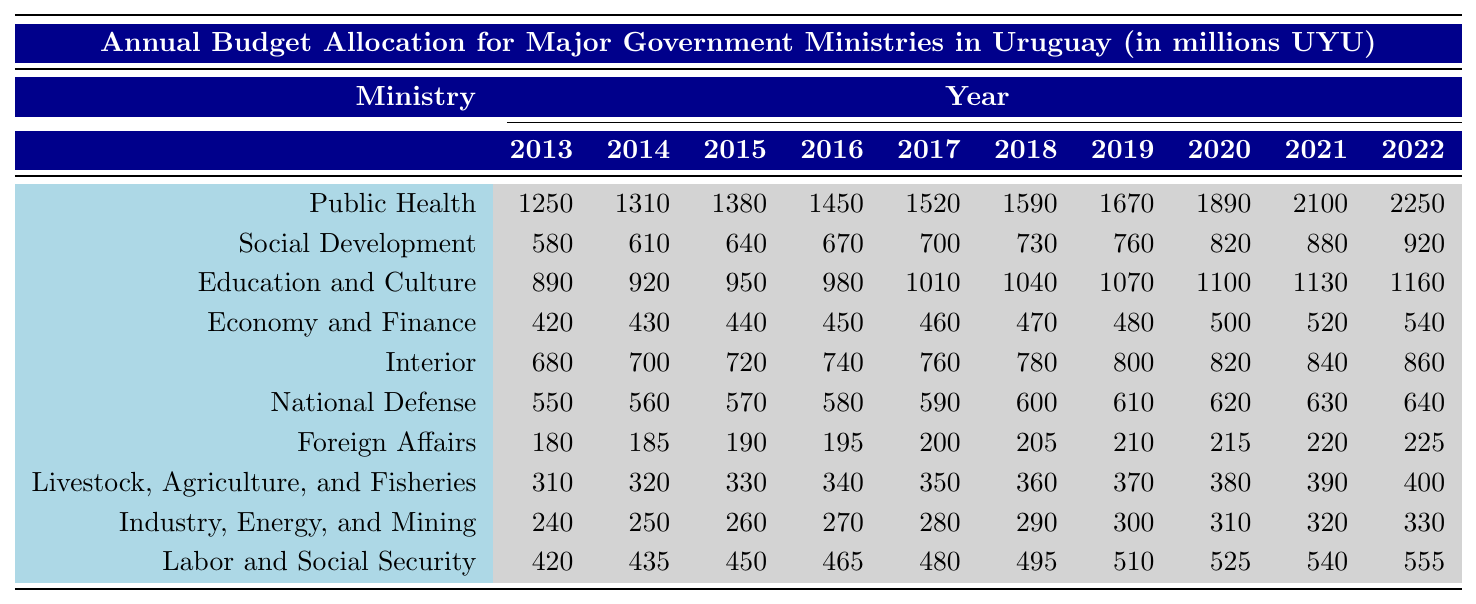What was the budget allocation for the Ministry of Public Health in 2020? In the column for the year 2020, the value for the Ministry of Public Health is listed directly as 1890.
Answer: 1890 Which ministry received the highest budget allocation in 2022? By examining the values for each ministry in the year 2022, the Ministry of Public Health has the highest value at 2250.
Answer: Ministry of Public Health What is the total budget allocated to the Ministry of Education and Culture over the last decade? To find the total, sum the values from 2013 to 2022: 890 + 920 + 950 + 980 + 1010 + 1040 + 1070 + 1100 + 1130 + 1160 = 10,450.
Answer: 10450 Did the budget allocation for the Ministry of National Defense increase every year from 2013 to 2022? Inspecting the values from 2013 (550) to 2022 (640), they consistently show an increase each year.
Answer: Yes What was the average budget allocation for the Ministry of Labor and Social Security during the last decade? To find the average, sum the values from 2013 to 2022: 420 + 435 + 450 + 465 + 480 + 495 + 510 + 525 + 540 + 555 = 5,570. Then divide by 10, which equals 557.
Answer: 557 In which year did the Ministry of Social Development have the lowest budget allocation? Looking at the values for the Ministry of Social Development, the lowest allocation is in 2013 with a value of 580.
Answer: 2013 What is the total budget allocated to the Ministry of Economy and Finance and the Ministry of Interior together over the decade? First, sum the budget of the Ministry of Economy and Finance over ten years: 420 + 430 + 440 + 450 + 460 + 470 + 480 + 500 + 520 + 540 = 4,410. Then sum the Ministry of Interior: 680 + 700 + 720 + 740 + 760 + 780 + 800 + 820 + 840 + 860 = 7,560. Finally, add both totals: 4,410 + 7,560 = 11,970.
Answer: 11970 How much did the budget for the Ministry of Livestock, Agriculture, and Fisheries increase from 2013 to 2022? The value for this ministry in 2013 is 310 and in 2022 it is 400. Thus, the increase is 400 - 310 = 90.
Answer: 90 Was there ever a year when the Ministry of Foreign Affairs received less than 200? Reviewing the values from 2013 to 2022, the budget for the Ministry of Foreign Affairs never dropped below 180 in 2013, maintaining an upward trend thereafter.
Answer: Yes Which ministry had the smallest budget allocation in 2014, and what was that amount? In 2014, comparing all ministries shows that the Ministry of Foreign Affairs had the smallest allocation of 185.
Answer: Ministry of Foreign Affairs, 185 